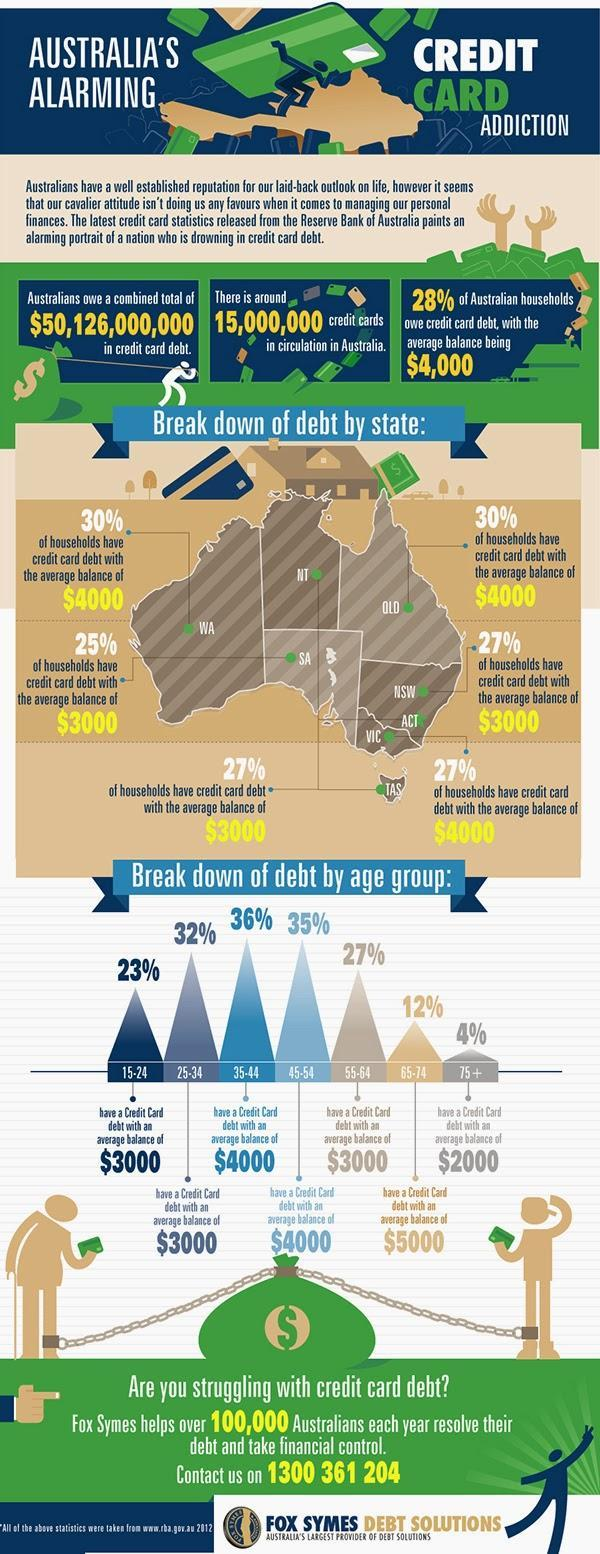Which age group of Australians have a credit card debt with an average balance of $2000?
Answer the question with a short phrase. 75+ What percentage of Australians have a credit card debt with an average balance of $2000? 4% What percentage of households have credit card debt with the average balance of $3000 in New South Wales? 27% What percentage of households have credit card debt with the average balance of $4000 in Western Australia? 30% What percentage of households have credit card debt with the average balance of $3000 in Southern Australia? 25% What is the number of credit cards being circulated in Australia? 15,000,000 Which age group of Australians have a credit card debt with an average balance of $5000? 65-74 What percentage of Australians have a credit card debt with an average balance of $5000? 12% What is the combined total of credit card debt owed by the Australians? $50,126,000,000 What percentage of households have credit card debt with the average balance of $3000 in Tasmania? 27% 